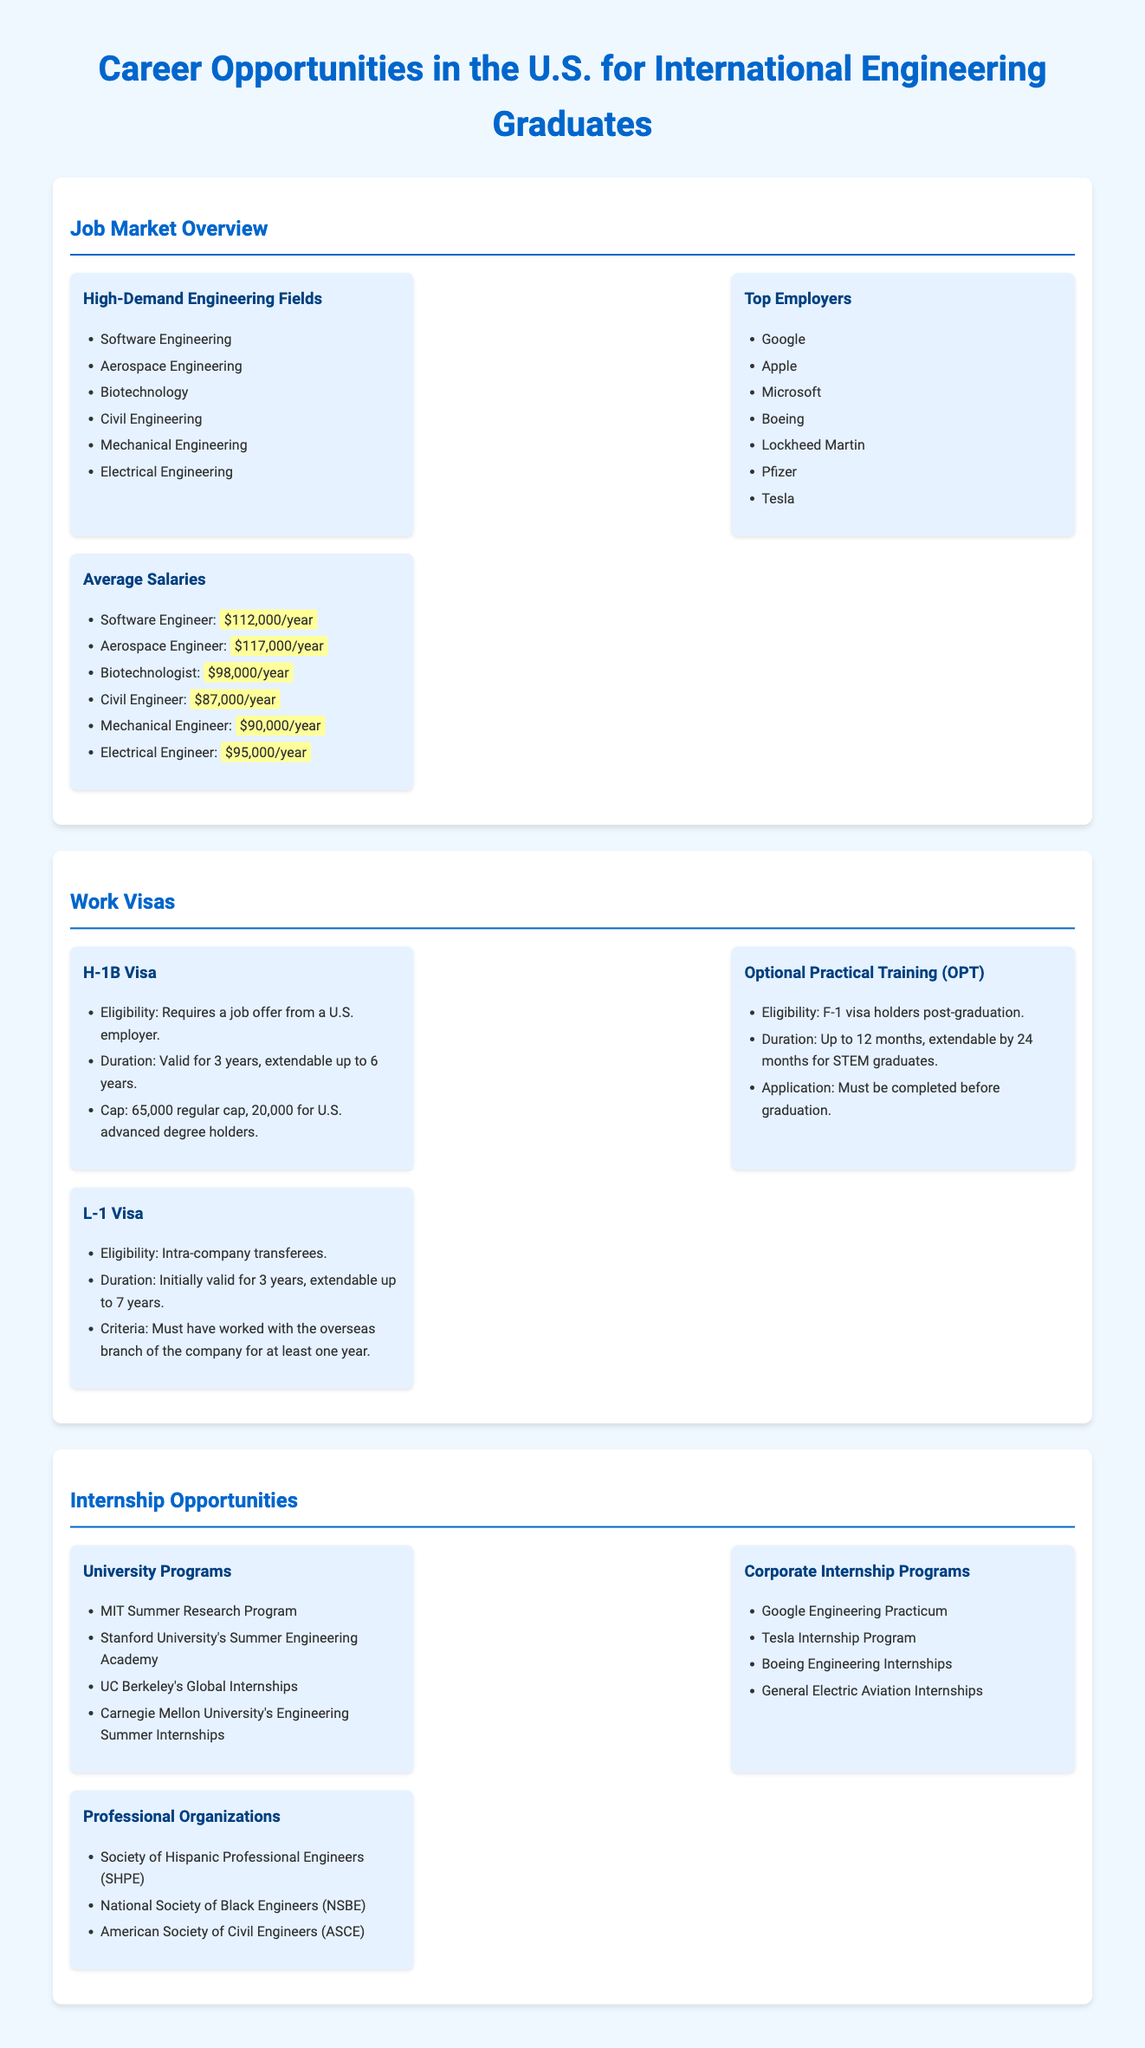what are the high-demand engineering fields? The document lists high-demand fields including Software Engineering, Aerospace Engineering, Biotechnology, Civil Engineering, Mechanical Engineering, and Electrical Engineering.
Answer: Software Engineering, Aerospace Engineering, Biotechnology, Civil Engineering, Mechanical Engineering, Electrical Engineering who are the top employers for engineering graduates? The document provides a list of top employers such as Google, Apple, Microsoft, Boeing, Lockheed Martin, Pfizer, and Tesla.
Answer: Google, Apple, Microsoft, Boeing, Lockheed Martin, Pfizer, Tesla what is the average salary for a Software Engineer? The document specifies that the average salary for a Software Engineer is outlined in the salary section, which states it is $112,000 per year.
Answer: $112,000/year how long is the H-1B visa valid? The H-1B visa has a duration of 3 years, which can be extended up to 6 years.
Answer: 3 years, extendable to 6 years what is the duration of Optional Practical Training for STEM graduates? The document states that Optional Practical Training can be extended by 24 months for STEM graduates.
Answer: 24 months which organization is mentioned for supporting Hispanic professional engineers? The document highlights the Society of Hispanic Professional Engineers (SHPE) as an organization.
Answer: Society of Hispanic Professional Engineers (SHPE) how many roles does the regular cap for the H-1B visa have? The document indicates that the regular cap for the H-1B visa is 65,000 roles.
Answer: 65,000 how many internship programs are listed under Corporate Internship Programs? The document includes four Corporate Internship Programs: Google Engineering Practicum, Tesla Internship Program, Boeing Engineering Internships, and General Electric Aviation Internships.
Answer: 4 what must be completed before applying for Optional Practical Training? The document notes that application for Optional Practical Training must be completed before graduation.
Answer: Before graduation 